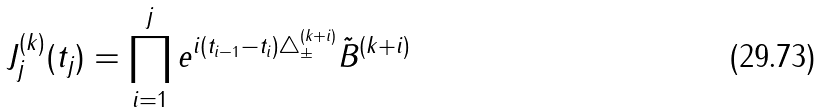<formula> <loc_0><loc_0><loc_500><loc_500>J ^ { ( k ) } _ { j } ( { t } _ { j } ) = \prod ^ { j } _ { i = 1 } e ^ { i ( t _ { i - 1 } - t _ { i } ) \triangle ^ { ( k + i ) } _ { \pm } } \tilde { B } ^ { ( k + i ) }</formula> 